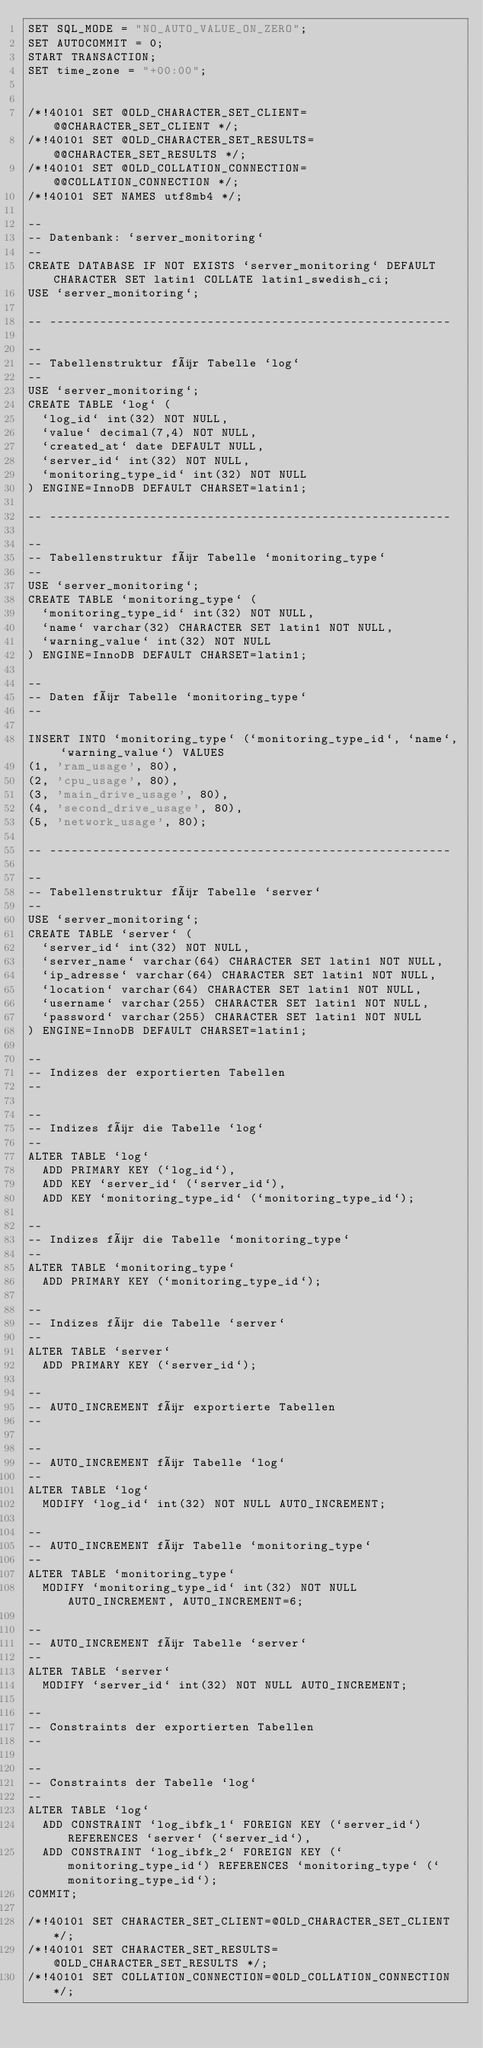Convert code to text. <code><loc_0><loc_0><loc_500><loc_500><_SQL_>SET SQL_MODE = "NO_AUTO_VALUE_ON_ZERO";
SET AUTOCOMMIT = 0;
START TRANSACTION;
SET time_zone = "+00:00";


/*!40101 SET @OLD_CHARACTER_SET_CLIENT=@@CHARACTER_SET_CLIENT */;
/*!40101 SET @OLD_CHARACTER_SET_RESULTS=@@CHARACTER_SET_RESULTS */;
/*!40101 SET @OLD_COLLATION_CONNECTION=@@COLLATION_CONNECTION */;
/*!40101 SET NAMES utf8mb4 */;

--
-- Datenbank: `server_monitoring`
--
CREATE DATABASE IF NOT EXISTS `server_monitoring` DEFAULT CHARACTER SET latin1 COLLATE latin1_swedish_ci;
USE `server_monitoring`;

-- --------------------------------------------------------

--
-- Tabellenstruktur für Tabelle `log`
--
USE `server_monitoring`;
CREATE TABLE `log` (
  `log_id` int(32) NOT NULL,
  `value` decimal(7,4) NOT NULL,
  `created_at` date DEFAULT NULL,
  `server_id` int(32) NOT NULL,
  `monitoring_type_id` int(32) NOT NULL
) ENGINE=InnoDB DEFAULT CHARSET=latin1;

-- --------------------------------------------------------

--
-- Tabellenstruktur für Tabelle `monitoring_type`
--
USE `server_monitoring`;
CREATE TABLE `monitoring_type` (
  `monitoring_type_id` int(32) NOT NULL,
  `name` varchar(32) CHARACTER SET latin1 NOT NULL,
  `warning_value` int(32) NOT NULL
) ENGINE=InnoDB DEFAULT CHARSET=latin1;

--
-- Daten für Tabelle `monitoring_type`
--

INSERT INTO `monitoring_type` (`monitoring_type_id`, `name`, `warning_value`) VALUES
(1, 'ram_usage', 80),
(2, 'cpu_usage', 80),
(3, 'main_drive_usage', 80),
(4, 'second_drive_usage', 80),
(5, 'network_usage', 80);

-- --------------------------------------------------------

--
-- Tabellenstruktur für Tabelle `server`
--
USE `server_monitoring`;
CREATE TABLE `server` (
  `server_id` int(32) NOT NULL,
  `server_name` varchar(64) CHARACTER SET latin1 NOT NULL,
  `ip_adresse` varchar(64) CHARACTER SET latin1 NOT NULL,
  `location` varchar(64) CHARACTER SET latin1 NOT NULL,
  `username` varchar(255) CHARACTER SET latin1 NOT NULL,
  `password` varchar(255) CHARACTER SET latin1 NOT NULL
) ENGINE=InnoDB DEFAULT CHARSET=latin1;

--
-- Indizes der exportierten Tabellen
--

--
-- Indizes für die Tabelle `log`
--
ALTER TABLE `log`
  ADD PRIMARY KEY (`log_id`),
  ADD KEY `server_id` (`server_id`),
  ADD KEY `monitoring_type_id` (`monitoring_type_id`);

--
-- Indizes für die Tabelle `monitoring_type`
--
ALTER TABLE `monitoring_type`
  ADD PRIMARY KEY (`monitoring_type_id`);

--
-- Indizes für die Tabelle `server`
--
ALTER TABLE `server`
  ADD PRIMARY KEY (`server_id`);

--
-- AUTO_INCREMENT für exportierte Tabellen
--

--
-- AUTO_INCREMENT für Tabelle `log`
--
ALTER TABLE `log`
  MODIFY `log_id` int(32) NOT NULL AUTO_INCREMENT;

--
-- AUTO_INCREMENT für Tabelle `monitoring_type`
--
ALTER TABLE `monitoring_type`
  MODIFY `monitoring_type_id` int(32) NOT NULL AUTO_INCREMENT, AUTO_INCREMENT=6;

--
-- AUTO_INCREMENT für Tabelle `server`
--
ALTER TABLE `server`
  MODIFY `server_id` int(32) NOT NULL AUTO_INCREMENT;

--
-- Constraints der exportierten Tabellen
--

--
-- Constraints der Tabelle `log`
--
ALTER TABLE `log`
  ADD CONSTRAINT `log_ibfk_1` FOREIGN KEY (`server_id`) REFERENCES `server` (`server_id`),
  ADD CONSTRAINT `log_ibfk_2` FOREIGN KEY (`monitoring_type_id`) REFERENCES `monitoring_type` (`monitoring_type_id`);
COMMIT;

/*!40101 SET CHARACTER_SET_CLIENT=@OLD_CHARACTER_SET_CLIENT */;
/*!40101 SET CHARACTER_SET_RESULTS=@OLD_CHARACTER_SET_RESULTS */;
/*!40101 SET COLLATION_CONNECTION=@OLD_COLLATION_CONNECTION */;
</code> 